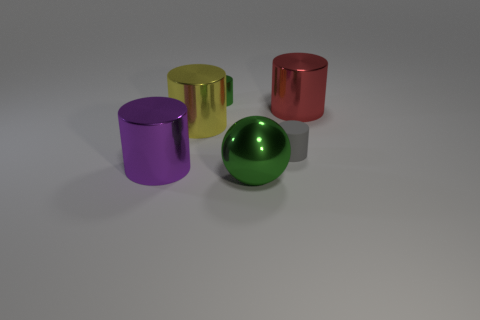Subtract all purple cylinders. How many cylinders are left? 4 Subtract all yellow cylinders. How many cylinders are left? 4 Subtract all brown cylinders. Subtract all cyan blocks. How many cylinders are left? 5 Add 3 small matte cubes. How many objects exist? 9 Subtract all cylinders. How many objects are left? 1 Add 6 large yellow metallic things. How many large yellow metallic things are left? 7 Add 6 big yellow metal spheres. How many big yellow metal spheres exist? 6 Subtract 1 purple cylinders. How many objects are left? 5 Subtract all big blue rubber blocks. Subtract all rubber cylinders. How many objects are left? 5 